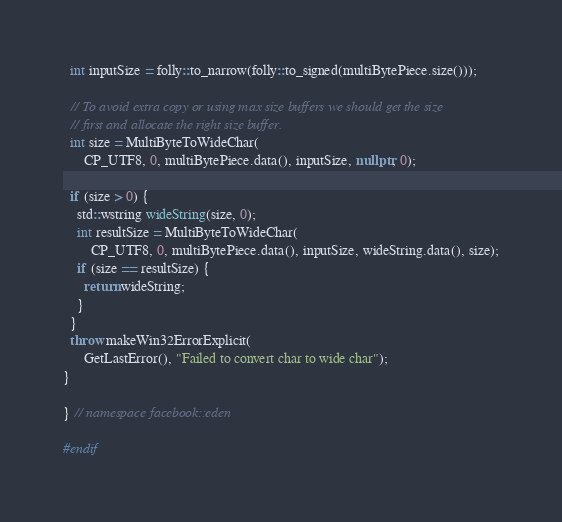Convert code to text. <code><loc_0><loc_0><loc_500><loc_500><_C++_>
  int inputSize = folly::to_narrow(folly::to_signed(multiBytePiece.size()));

  // To avoid extra copy or using max size buffers we should get the size
  // first and allocate the right size buffer.
  int size = MultiByteToWideChar(
      CP_UTF8, 0, multiBytePiece.data(), inputSize, nullptr, 0);

  if (size > 0) {
    std::wstring wideString(size, 0);
    int resultSize = MultiByteToWideChar(
        CP_UTF8, 0, multiBytePiece.data(), inputSize, wideString.data(), size);
    if (size == resultSize) {
      return wideString;
    }
  }
  throw makeWin32ErrorExplicit(
      GetLastError(), "Failed to convert char to wide char");
}

} // namespace facebook::eden

#endif
</code> 